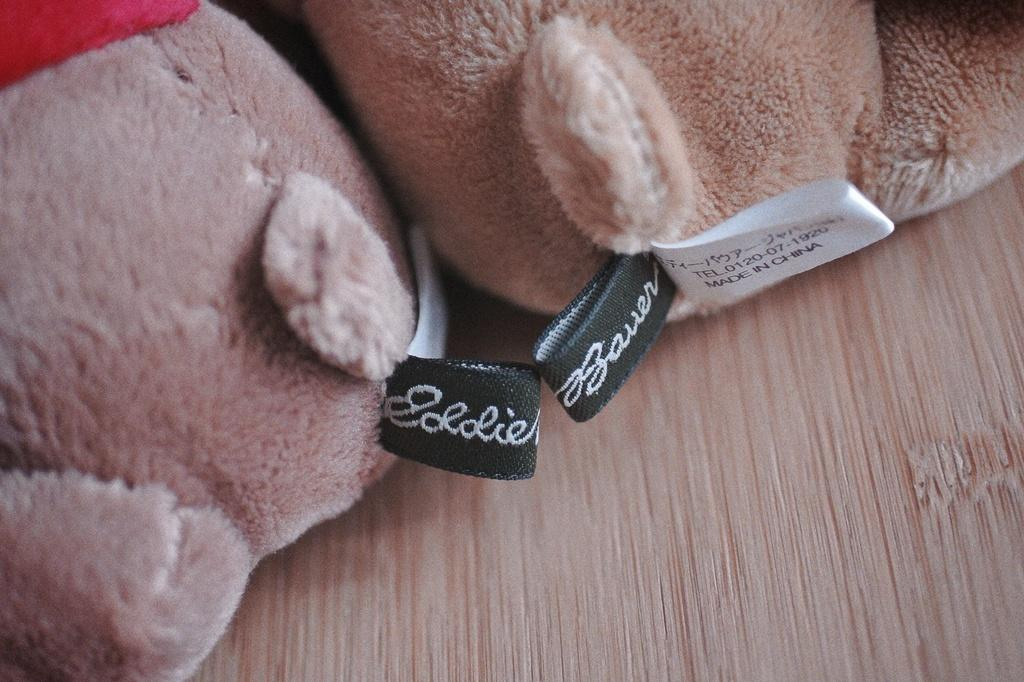What type of toy is in the image? There is a teddy bear in the image. What color is the teddy bear? The teddy bear is pink in color. Where is the teddy bear located in the image? The teddy bear is present on a table. How does the teddy bear express pain in the image? The teddy bear does not express pain in the image, as it is an inanimate object and cannot feel or express emotions. 